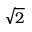Convert formula to latex. <formula><loc_0><loc_0><loc_500><loc_500>\sqrt { 2 }</formula> 